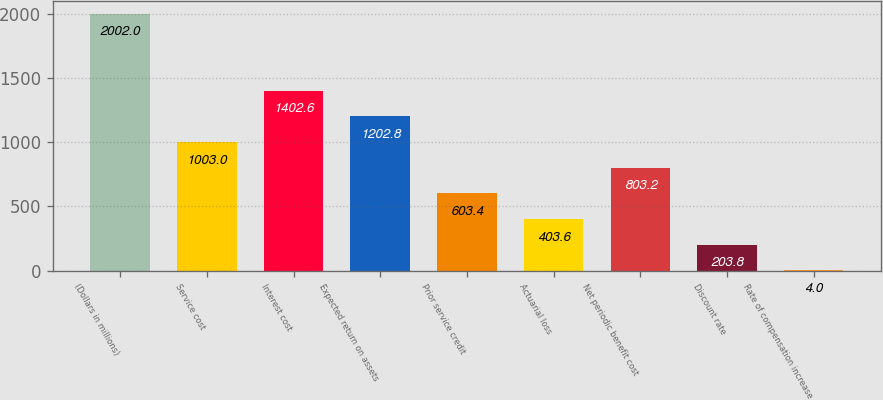Convert chart. <chart><loc_0><loc_0><loc_500><loc_500><bar_chart><fcel>(Dollars in millions)<fcel>Service cost<fcel>Interest cost<fcel>Expected return on assets<fcel>Prior service credit<fcel>Actuarial loss<fcel>Net periodic benefit cost<fcel>Discount rate<fcel>Rate of compensation increase<nl><fcel>2002<fcel>1003<fcel>1402.6<fcel>1202.8<fcel>603.4<fcel>403.6<fcel>803.2<fcel>203.8<fcel>4<nl></chart> 